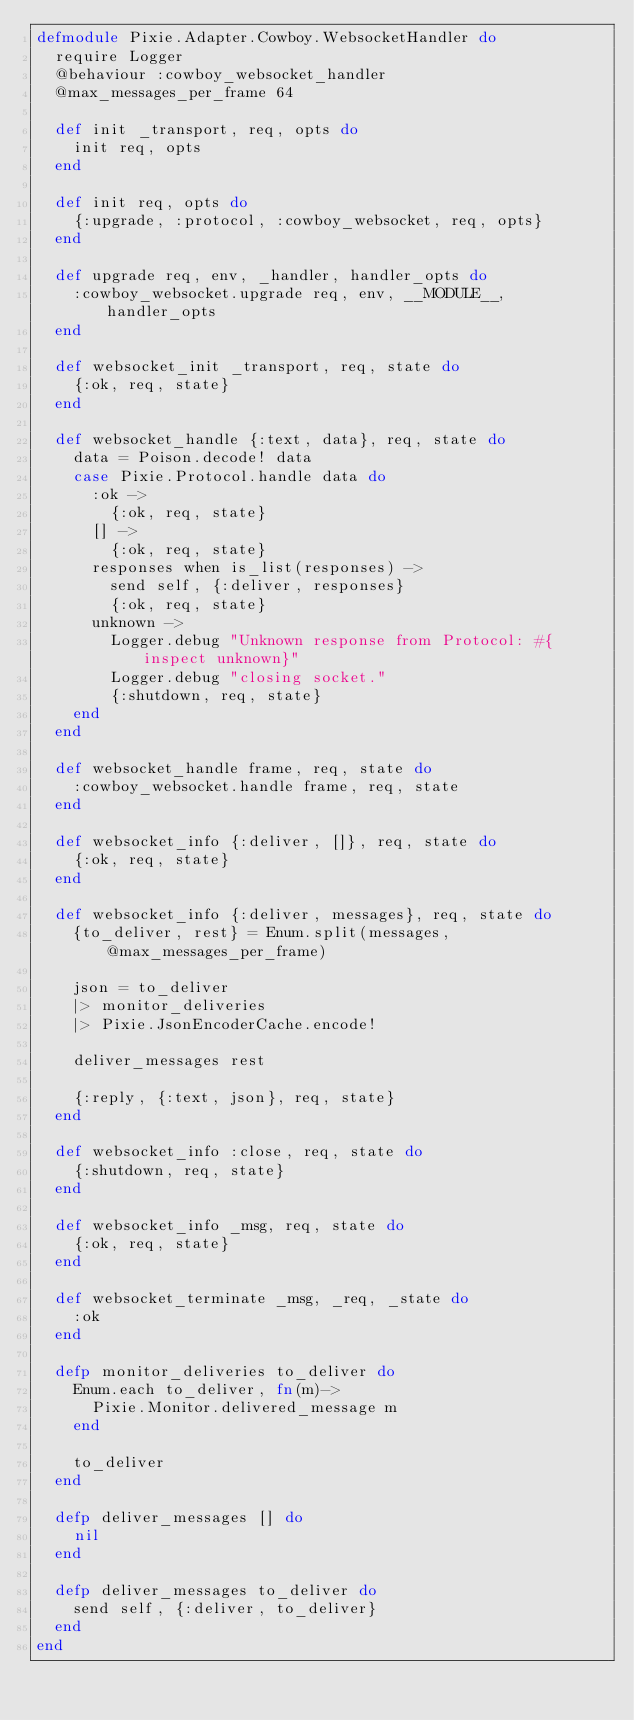Convert code to text. <code><loc_0><loc_0><loc_500><loc_500><_Elixir_>defmodule Pixie.Adapter.Cowboy.WebsocketHandler do
  require Logger
  @behaviour :cowboy_websocket_handler
  @max_messages_per_frame 64

  def init _transport, req, opts do
    init req, opts
  end

  def init req, opts do
    {:upgrade, :protocol, :cowboy_websocket, req, opts}
  end

  def upgrade req, env, _handler, handler_opts do
    :cowboy_websocket.upgrade req, env, __MODULE__, handler_opts
  end

  def websocket_init _transport, req, state do
    {:ok, req, state}
  end

  def websocket_handle {:text, data}, req, state do
    data = Poison.decode! data
    case Pixie.Protocol.handle data do
      :ok ->
        {:ok, req, state}
      [] ->
        {:ok, req, state}
      responses when is_list(responses) ->
        send self, {:deliver, responses}
        {:ok, req, state}
      unknown ->
        Logger.debug "Unknown response from Protocol: #{inspect unknown}"
        Logger.debug "closing socket."
        {:shutdown, req, state}
    end
  end

  def websocket_handle frame, req, state do
    :cowboy_websocket.handle frame, req, state
  end

  def websocket_info {:deliver, []}, req, state do
    {:ok, req, state}
  end

  def websocket_info {:deliver, messages}, req, state do
    {to_deliver, rest} = Enum.split(messages, @max_messages_per_frame)

    json = to_deliver
    |> monitor_deliveries
    |> Pixie.JsonEncoderCache.encode!

    deliver_messages rest

    {:reply, {:text, json}, req, state}
  end

  def websocket_info :close, req, state do
    {:shutdown, req, state}
  end

  def websocket_info _msg, req, state do
    {:ok, req, state}
  end

  def websocket_terminate _msg, _req, _state do
    :ok
  end

  defp monitor_deliveries to_deliver do
    Enum.each to_deliver, fn(m)->
      Pixie.Monitor.delivered_message m
    end

    to_deliver
  end

  defp deliver_messages [] do
    nil
  end

  defp deliver_messages to_deliver do
    send self, {:deliver, to_deliver}
  end
end
</code> 